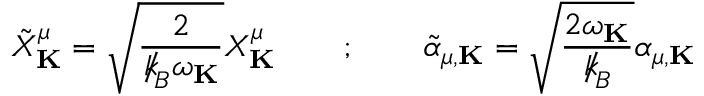Convert formula to latex. <formula><loc_0><loc_0><loc_500><loc_500>{ \tilde { X } } _ { K } ^ { \mu } = \sqrt { \frac { 2 } { { \slash \, k } _ { \, { B } } \omega _ { K } } } X _ { K } ^ { \mu } \quad ; \quad { \tilde { \alpha } } _ { \mu , { K } } = \sqrt { \frac { 2 \omega _ { K } } { { \slash \, k } _ { \, { B } } } } \alpha _ { \mu , { K } }</formula> 